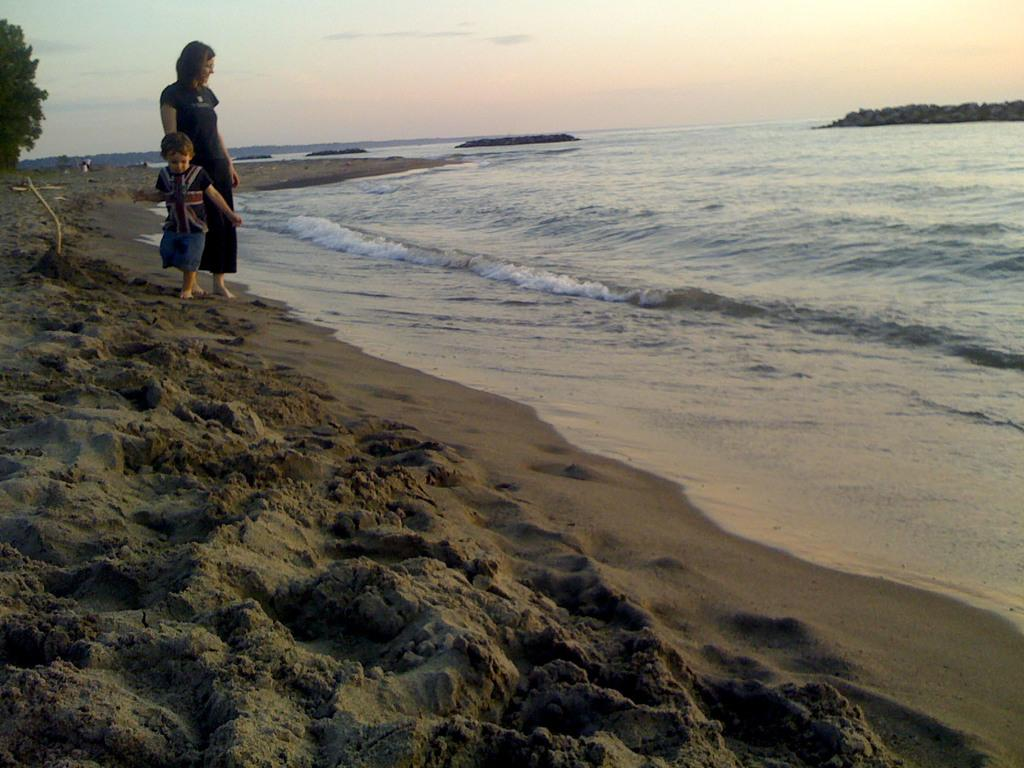What is present in the image that is related to water? There is water in the image. Who is standing near the water? A woman and a kid are standing near the water. What type of terrain is visible in the image? There is sand in the image. What other natural elements can be seen in the image? There is a tree and mountains in the image. What part of the natural environment is visible in the image? The sky is visible in the image. What word is the woman saying in the image? There is no indication of any spoken words in the image, so it cannot be determined what the woman might be saying. How many ants can be seen crawling on the tree in the image? There are no ants present in the image; only the tree is visible. 